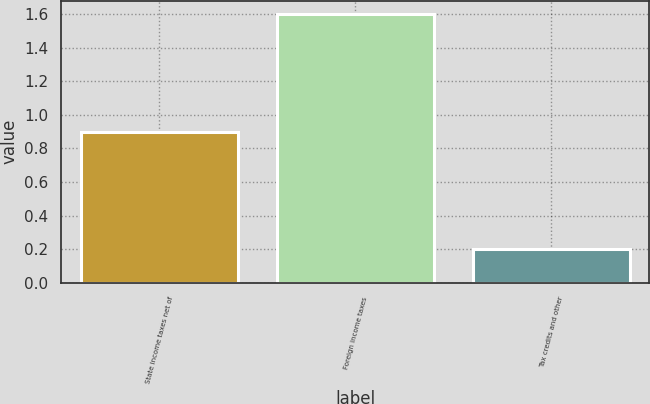<chart> <loc_0><loc_0><loc_500><loc_500><bar_chart><fcel>State income taxes net of<fcel>Foreign income taxes<fcel>Tax credits and other<nl><fcel>0.9<fcel>1.6<fcel>0.2<nl></chart> 